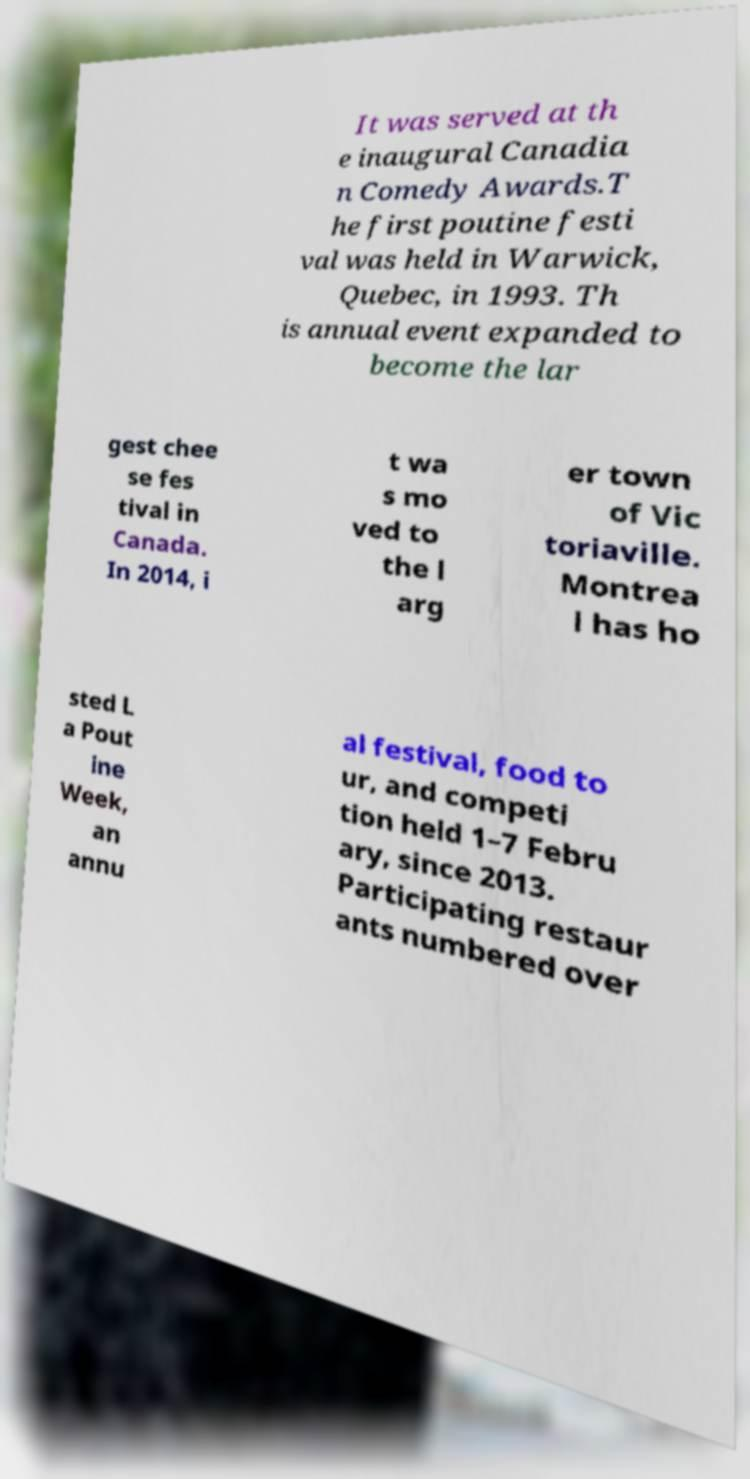For documentation purposes, I need the text within this image transcribed. Could you provide that? It was served at th e inaugural Canadia n Comedy Awards.T he first poutine festi val was held in Warwick, Quebec, in 1993. Th is annual event expanded to become the lar gest chee se fes tival in Canada. In 2014, i t wa s mo ved to the l arg er town of Vic toriaville. Montrea l has ho sted L a Pout ine Week, an annu al festival, food to ur, and competi tion held 1–7 Febru ary, since 2013. Participating restaur ants numbered over 